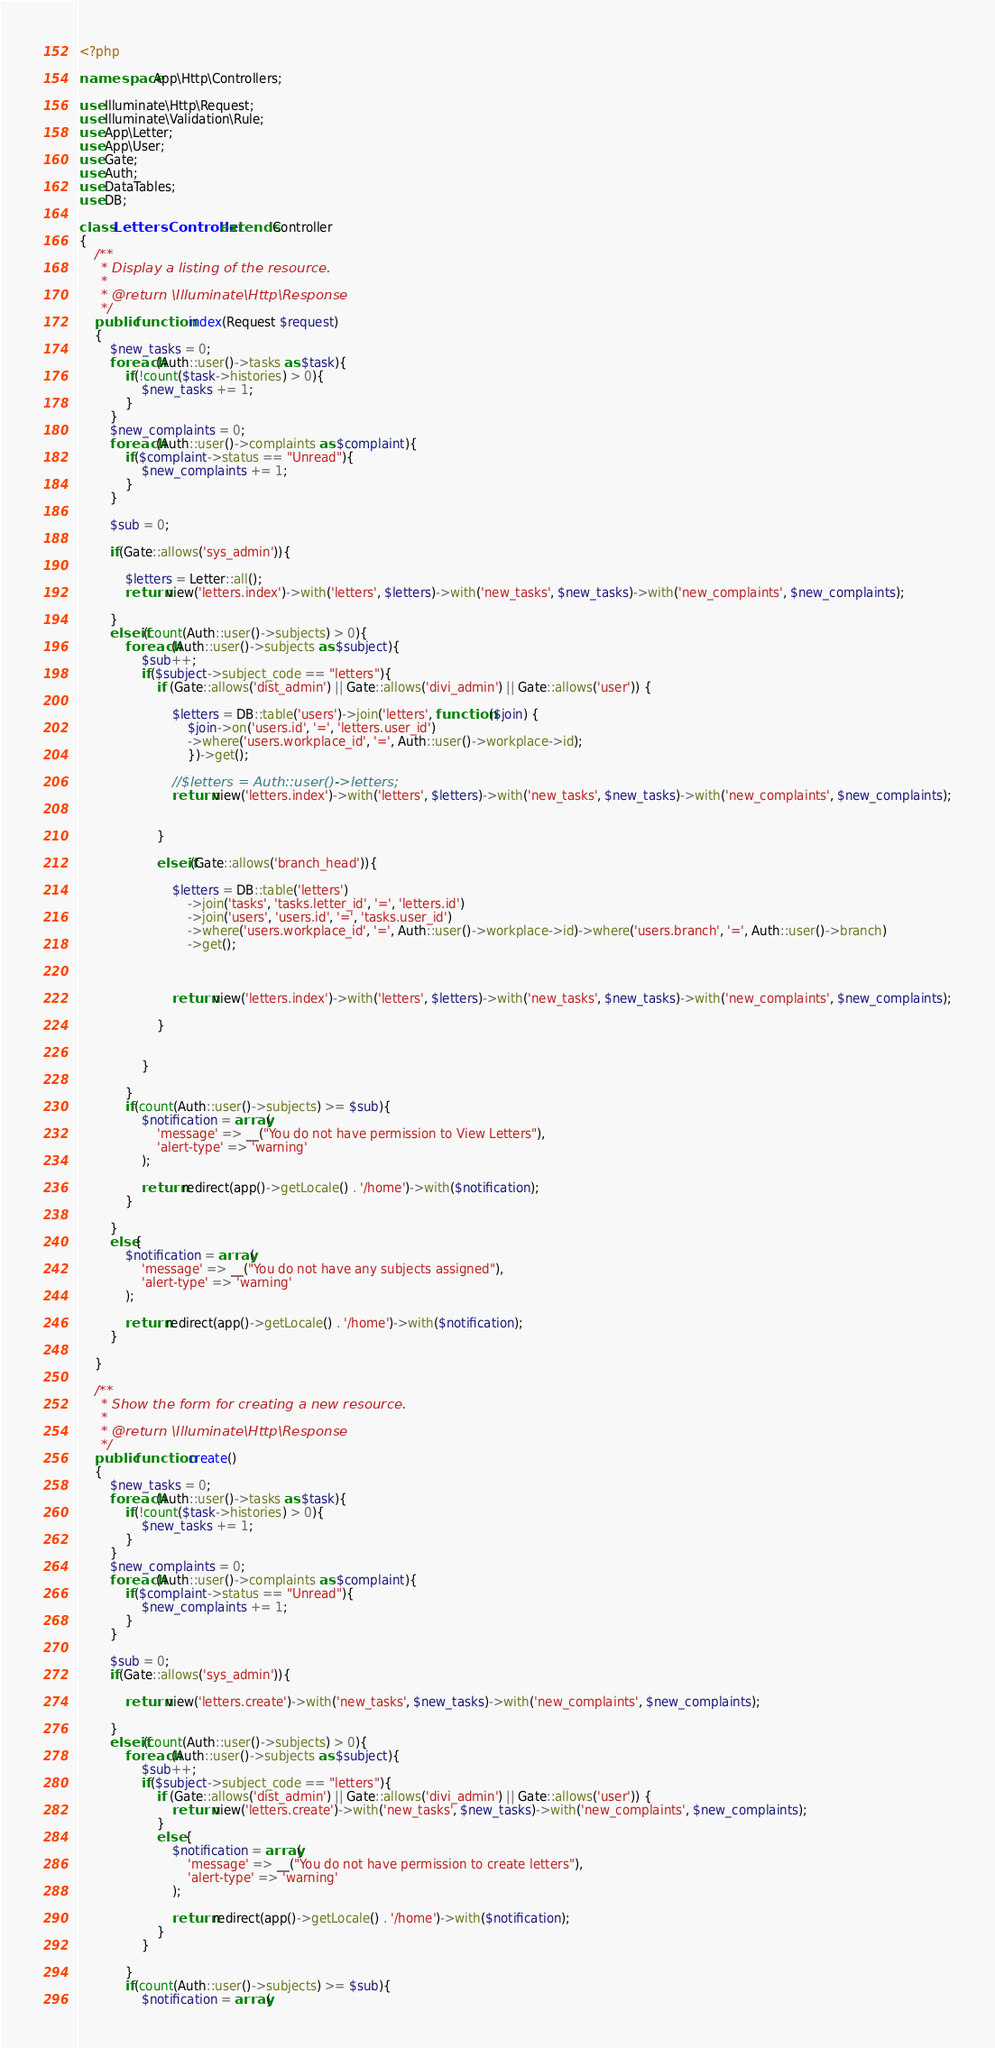<code> <loc_0><loc_0><loc_500><loc_500><_PHP_><?php

namespace App\Http\Controllers;

use Illuminate\Http\Request;
use Illuminate\Validation\Rule;
use App\Letter;
use App\User;
use Gate;
use Auth;
use DataTables;
use DB;

class LettersController extends Controller
{
    /**
     * Display a listing of the resource.
     *
     * @return \Illuminate\Http\Response
     */
    public function index(Request $request)
    {
        $new_tasks = 0;
        foreach(Auth::user()->tasks as $task){
            if(!count($task->histories) > 0){
                $new_tasks += 1;
            }
        }
        $new_complaints = 0;
        foreach(Auth::user()->complaints as $complaint){
            if($complaint->status == "Unread"){
                $new_complaints += 1;
            }
        }

        $sub = 0;

        if(Gate::allows('sys_admin')){

            $letters = Letter::all();
            return view('letters.index')->with('letters', $letters)->with('new_tasks', $new_tasks)->with('new_complaints', $new_complaints);

        }
        elseif(count(Auth::user()->subjects) > 0){
            foreach(Auth::user()->subjects as $subject){
                $sub++;
                if($subject->subject_code == "letters"){
                    if (Gate::allows('dist_admin') || Gate::allows('divi_admin') || Gate::allows('user')) {
                        
                        $letters = DB::table('users')->join('letters', function ($join) {
                            $join->on('users.id', '=', 'letters.user_id')
                            ->where('users.workplace_id', '=', Auth::user()->workplace->id);
                            })->get();
            
                        //$letters = Auth::user()->letters;
                        return view('letters.index')->with('letters', $letters)->with('new_tasks', $new_tasks)->with('new_complaints', $new_complaints);
                    
                
                    } 
            
                    elseif(Gate::allows('branch_head')){

                        $letters = DB::table('letters')
                            ->join('tasks', 'tasks.letter_id', '=', 'letters.id')
                            ->join('users', 'users.id', '=', 'tasks.user_id')
                            ->where('users.workplace_id', '=', Auth::user()->workplace->id)->where('users.branch', '=', Auth::user()->branch)
                            ->get();

                        
                            
                        return view('letters.index')->with('letters', $letters)->with('new_tasks', $new_tasks)->with('new_complaints', $new_complaints);
                    
                    }
                    
                    
                }
               
            }
            if(count(Auth::user()->subjects) >= $sub){
                $notification = array(
                    'message' => __("You do not have permission to View Letters"),
                    'alert-type' => 'warning'
                );
                
                return redirect(app()->getLocale() . '/home')->with($notification);
            }
            
        }
        else{
            $notification = array(
                'message' => __("You do not have any subjects assigned"),
                'alert-type' => 'warning'
            );
            
            return redirect(app()->getLocale() . '/home')->with($notification);
        }
        
    }

    /**
     * Show the form for creating a new resource.
     *
     * @return \Illuminate\Http\Response
     */
    public function create()
    {
        $new_tasks = 0;
        foreach(Auth::user()->tasks as $task){
            if(!count($task->histories) > 0){
                $new_tasks += 1;
            }
        }
        $new_complaints = 0;
        foreach(Auth::user()->complaints as $complaint){
            if($complaint->status == "Unread"){
                $new_complaints += 1;
            }
        }

        $sub = 0;
        if(Gate::allows('sys_admin')){

            return view('letters.create')->with('new_tasks', $new_tasks)->with('new_complaints', $new_complaints);

        }
        elseif(count(Auth::user()->subjects) > 0){
            foreach(Auth::user()->subjects as $subject){
                $sub++;
                if($subject->subject_code == "letters"){
                    if (Gate::allows('dist_admin') || Gate::allows('divi_admin') || Gate::allows('user')) {
                        return view('letters.create')->with('new_tasks', $new_tasks)->with('new_complaints', $new_complaints);
                    }
                    else {
                        $notification = array(
                            'message' => __("You do not have permission to create letters"),
                            'alert-type' => 'warning'
                        );
                        
                        return redirect(app()->getLocale() . '/home')->with($notification);
                    }
                }
                
            }
            if(count(Auth::user()->subjects) >= $sub){
                $notification = array(</code> 